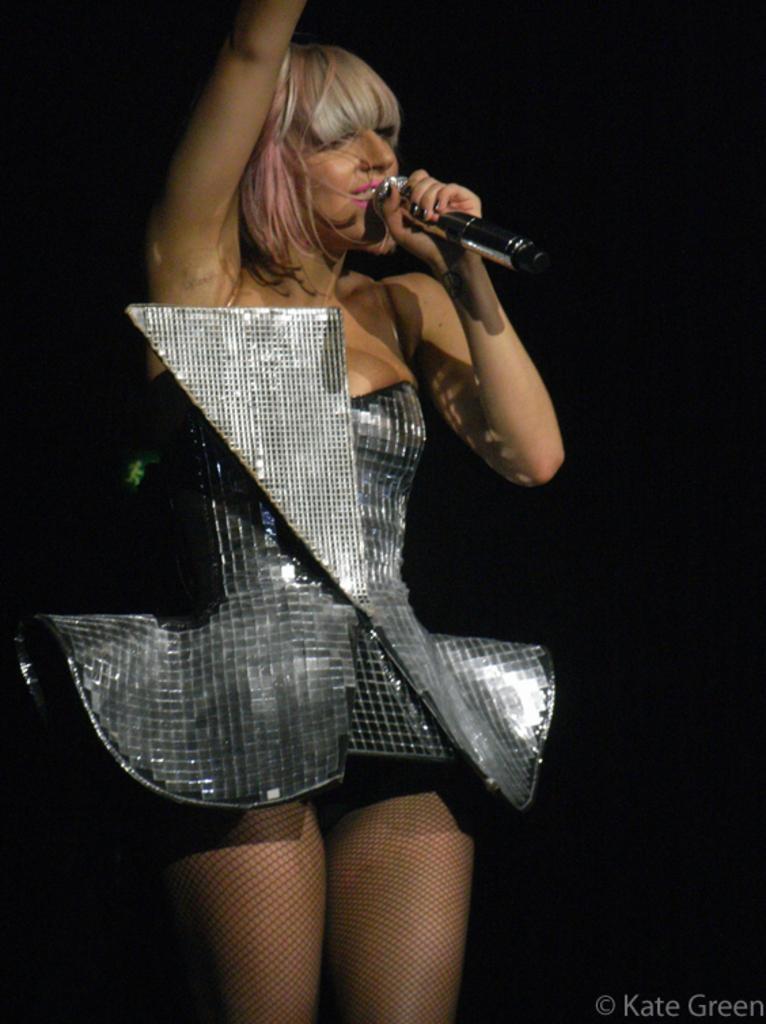Please provide a concise description of this image. Here we can see a woman in a costume singing a song with a microphone in her hand 